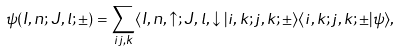Convert formula to latex. <formula><loc_0><loc_0><loc_500><loc_500>\psi ( I , n ; J , l ; \pm ) = \sum _ { i j , k } \langle I , n , \uparrow ; J , l , \downarrow | i , k ; j , k ; \pm \rangle \langle i , k ; j , k ; \pm | \psi \rangle ,</formula> 